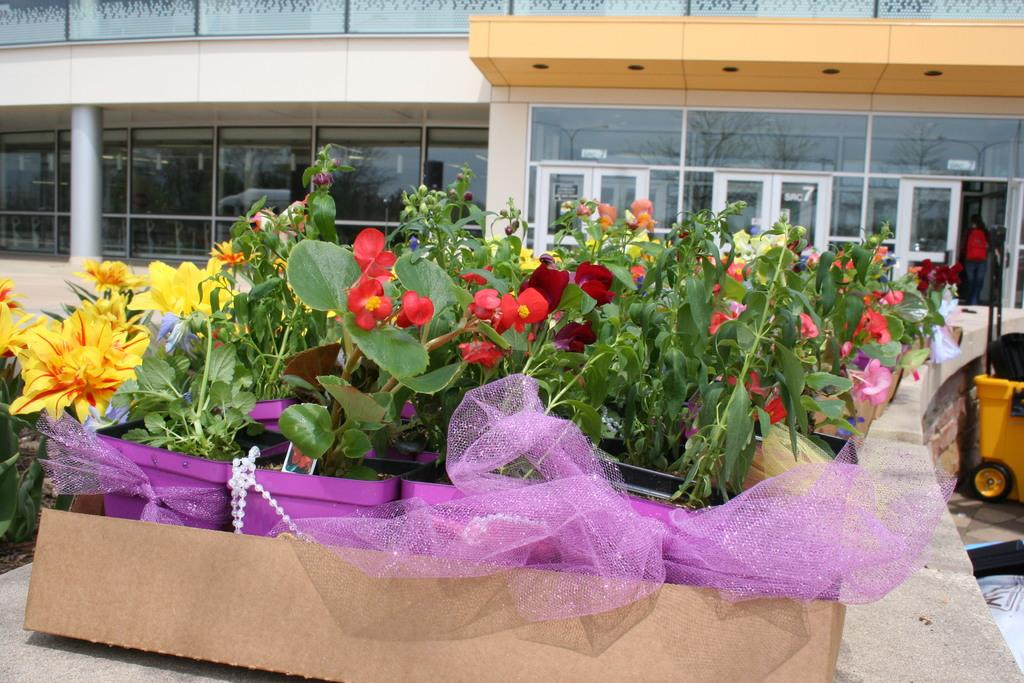What type of plants can be seen in the image? There are flowers in the image. What objects are located in the front of the image? There are boxes in the front of the image. What can be seen in the background of the image? There is a building in the background of the image. What is on the right side of the image? There is a yellow-colored trolley and a person on the right side of the image. Can you tell me how many people are in the group of flowers in the image? There is no group of people in the image, and the flowers are not associated with any people. What arithmetic problem can be solved using the number of boxes and the number of flowers in the image? There is no arithmetic problem presented in the image, as it only contains visual information about flowers, boxes, a building, a yellow-colored trolley, and a person. 